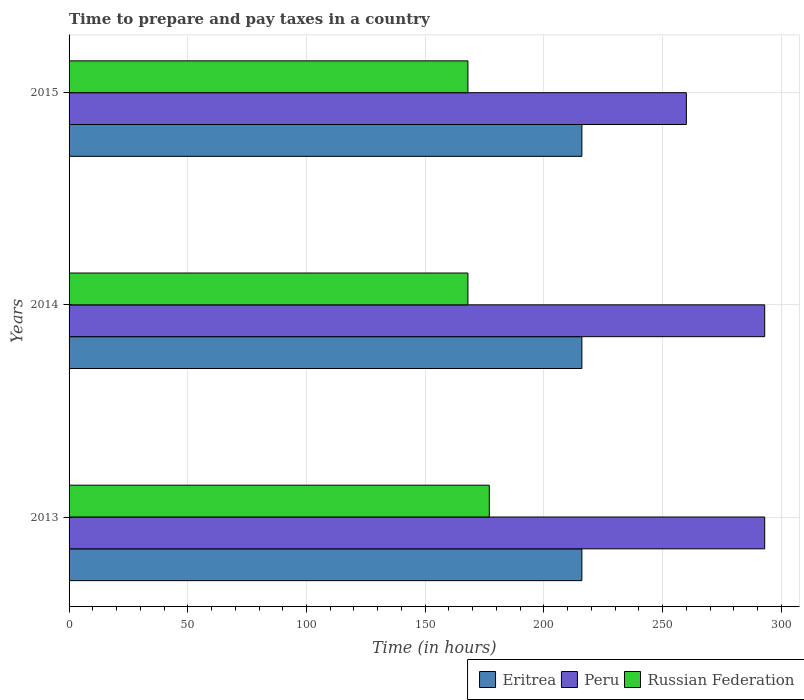How many groups of bars are there?
Make the answer very short. 3. How many bars are there on the 1st tick from the top?
Your answer should be very brief. 3. What is the number of hours required to prepare and pay taxes in Peru in 2013?
Offer a terse response. 293. Across all years, what is the maximum number of hours required to prepare and pay taxes in Peru?
Make the answer very short. 293. Across all years, what is the minimum number of hours required to prepare and pay taxes in Russian Federation?
Provide a short and direct response. 168. What is the total number of hours required to prepare and pay taxes in Peru in the graph?
Give a very brief answer. 846. What is the difference between the number of hours required to prepare and pay taxes in Russian Federation in 2013 and that in 2015?
Ensure brevity in your answer.  9. What is the difference between the number of hours required to prepare and pay taxes in Russian Federation in 2014 and the number of hours required to prepare and pay taxes in Eritrea in 2015?
Your answer should be very brief. -48. What is the average number of hours required to prepare and pay taxes in Russian Federation per year?
Your answer should be compact. 171. In the year 2013, what is the difference between the number of hours required to prepare and pay taxes in Peru and number of hours required to prepare and pay taxes in Russian Federation?
Your answer should be very brief. 116. What is the ratio of the number of hours required to prepare and pay taxes in Russian Federation in 2013 to that in 2015?
Your answer should be compact. 1.05. Is the difference between the number of hours required to prepare and pay taxes in Peru in 2013 and 2015 greater than the difference between the number of hours required to prepare and pay taxes in Russian Federation in 2013 and 2015?
Your response must be concise. Yes. What is the difference between the highest and the second highest number of hours required to prepare and pay taxes in Eritrea?
Your response must be concise. 0. What is the difference between the highest and the lowest number of hours required to prepare and pay taxes in Eritrea?
Keep it short and to the point. 0. Is the sum of the number of hours required to prepare and pay taxes in Peru in 2013 and 2015 greater than the maximum number of hours required to prepare and pay taxes in Eritrea across all years?
Provide a succinct answer. Yes. What does the 3rd bar from the top in 2013 represents?
Your answer should be very brief. Eritrea. What does the 3rd bar from the bottom in 2015 represents?
Offer a very short reply. Russian Federation. What is the difference between two consecutive major ticks on the X-axis?
Give a very brief answer. 50. Are the values on the major ticks of X-axis written in scientific E-notation?
Give a very brief answer. No. What is the title of the graph?
Keep it short and to the point. Time to prepare and pay taxes in a country. Does "Sweden" appear as one of the legend labels in the graph?
Offer a terse response. No. What is the label or title of the X-axis?
Provide a succinct answer. Time (in hours). What is the Time (in hours) in Eritrea in 2013?
Your response must be concise. 216. What is the Time (in hours) in Peru in 2013?
Offer a terse response. 293. What is the Time (in hours) in Russian Federation in 2013?
Your response must be concise. 177. What is the Time (in hours) of Eritrea in 2014?
Provide a succinct answer. 216. What is the Time (in hours) of Peru in 2014?
Give a very brief answer. 293. What is the Time (in hours) in Russian Federation in 2014?
Your answer should be compact. 168. What is the Time (in hours) of Eritrea in 2015?
Provide a succinct answer. 216. What is the Time (in hours) of Peru in 2015?
Offer a terse response. 260. What is the Time (in hours) of Russian Federation in 2015?
Provide a short and direct response. 168. Across all years, what is the maximum Time (in hours) of Eritrea?
Make the answer very short. 216. Across all years, what is the maximum Time (in hours) in Peru?
Ensure brevity in your answer.  293. Across all years, what is the maximum Time (in hours) in Russian Federation?
Provide a short and direct response. 177. Across all years, what is the minimum Time (in hours) in Eritrea?
Your response must be concise. 216. Across all years, what is the minimum Time (in hours) of Peru?
Offer a very short reply. 260. Across all years, what is the minimum Time (in hours) in Russian Federation?
Make the answer very short. 168. What is the total Time (in hours) of Eritrea in the graph?
Provide a short and direct response. 648. What is the total Time (in hours) of Peru in the graph?
Your answer should be compact. 846. What is the total Time (in hours) of Russian Federation in the graph?
Provide a succinct answer. 513. What is the difference between the Time (in hours) in Peru in 2013 and that in 2014?
Offer a very short reply. 0. What is the difference between the Time (in hours) in Eritrea in 2013 and that in 2015?
Offer a terse response. 0. What is the difference between the Time (in hours) of Peru in 2013 and that in 2015?
Your response must be concise. 33. What is the difference between the Time (in hours) of Eritrea in 2014 and that in 2015?
Keep it short and to the point. 0. What is the difference between the Time (in hours) of Russian Federation in 2014 and that in 2015?
Offer a very short reply. 0. What is the difference between the Time (in hours) of Eritrea in 2013 and the Time (in hours) of Peru in 2014?
Make the answer very short. -77. What is the difference between the Time (in hours) of Eritrea in 2013 and the Time (in hours) of Russian Federation in 2014?
Ensure brevity in your answer.  48. What is the difference between the Time (in hours) of Peru in 2013 and the Time (in hours) of Russian Federation in 2014?
Provide a short and direct response. 125. What is the difference between the Time (in hours) of Eritrea in 2013 and the Time (in hours) of Peru in 2015?
Your answer should be very brief. -44. What is the difference between the Time (in hours) in Peru in 2013 and the Time (in hours) in Russian Federation in 2015?
Provide a succinct answer. 125. What is the difference between the Time (in hours) of Eritrea in 2014 and the Time (in hours) of Peru in 2015?
Offer a terse response. -44. What is the difference between the Time (in hours) of Eritrea in 2014 and the Time (in hours) of Russian Federation in 2015?
Offer a very short reply. 48. What is the difference between the Time (in hours) in Peru in 2014 and the Time (in hours) in Russian Federation in 2015?
Make the answer very short. 125. What is the average Time (in hours) of Eritrea per year?
Your response must be concise. 216. What is the average Time (in hours) of Peru per year?
Ensure brevity in your answer.  282. What is the average Time (in hours) of Russian Federation per year?
Keep it short and to the point. 171. In the year 2013, what is the difference between the Time (in hours) of Eritrea and Time (in hours) of Peru?
Make the answer very short. -77. In the year 2013, what is the difference between the Time (in hours) of Eritrea and Time (in hours) of Russian Federation?
Your answer should be very brief. 39. In the year 2013, what is the difference between the Time (in hours) of Peru and Time (in hours) of Russian Federation?
Ensure brevity in your answer.  116. In the year 2014, what is the difference between the Time (in hours) in Eritrea and Time (in hours) in Peru?
Keep it short and to the point. -77. In the year 2014, what is the difference between the Time (in hours) of Peru and Time (in hours) of Russian Federation?
Give a very brief answer. 125. In the year 2015, what is the difference between the Time (in hours) in Eritrea and Time (in hours) in Peru?
Ensure brevity in your answer.  -44. In the year 2015, what is the difference between the Time (in hours) in Peru and Time (in hours) in Russian Federation?
Make the answer very short. 92. What is the ratio of the Time (in hours) of Peru in 2013 to that in 2014?
Your answer should be compact. 1. What is the ratio of the Time (in hours) in Russian Federation in 2013 to that in 2014?
Make the answer very short. 1.05. What is the ratio of the Time (in hours) of Peru in 2013 to that in 2015?
Offer a very short reply. 1.13. What is the ratio of the Time (in hours) of Russian Federation in 2013 to that in 2015?
Provide a short and direct response. 1.05. What is the ratio of the Time (in hours) of Eritrea in 2014 to that in 2015?
Provide a succinct answer. 1. What is the ratio of the Time (in hours) of Peru in 2014 to that in 2015?
Make the answer very short. 1.13. What is the ratio of the Time (in hours) in Russian Federation in 2014 to that in 2015?
Your answer should be compact. 1. What is the difference between the highest and the second highest Time (in hours) of Peru?
Offer a very short reply. 0. What is the difference between the highest and the lowest Time (in hours) in Russian Federation?
Your answer should be very brief. 9. 